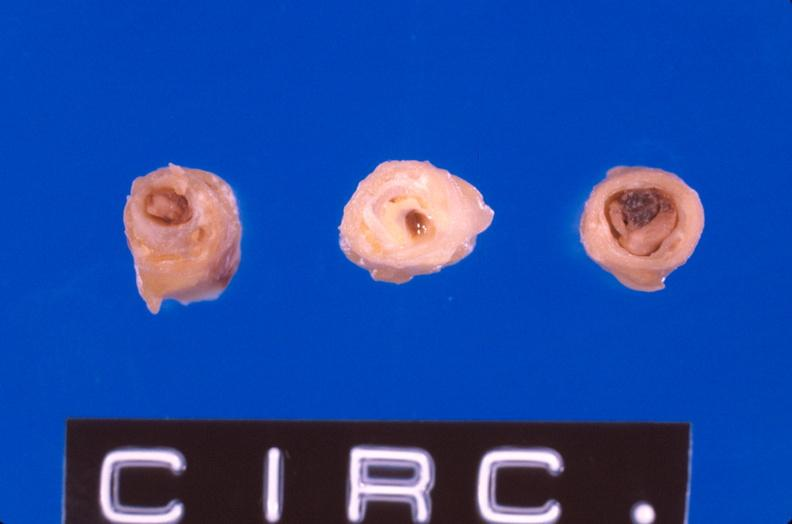does nodular tumor show coronary artery atherosclerosis?
Answer the question using a single word or phrase. No 